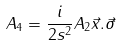<formula> <loc_0><loc_0><loc_500><loc_500>A _ { 4 } = \frac { i } { 2 s ^ { 2 } } A _ { 2 } \vec { x } . \vec { \sigma }</formula> 